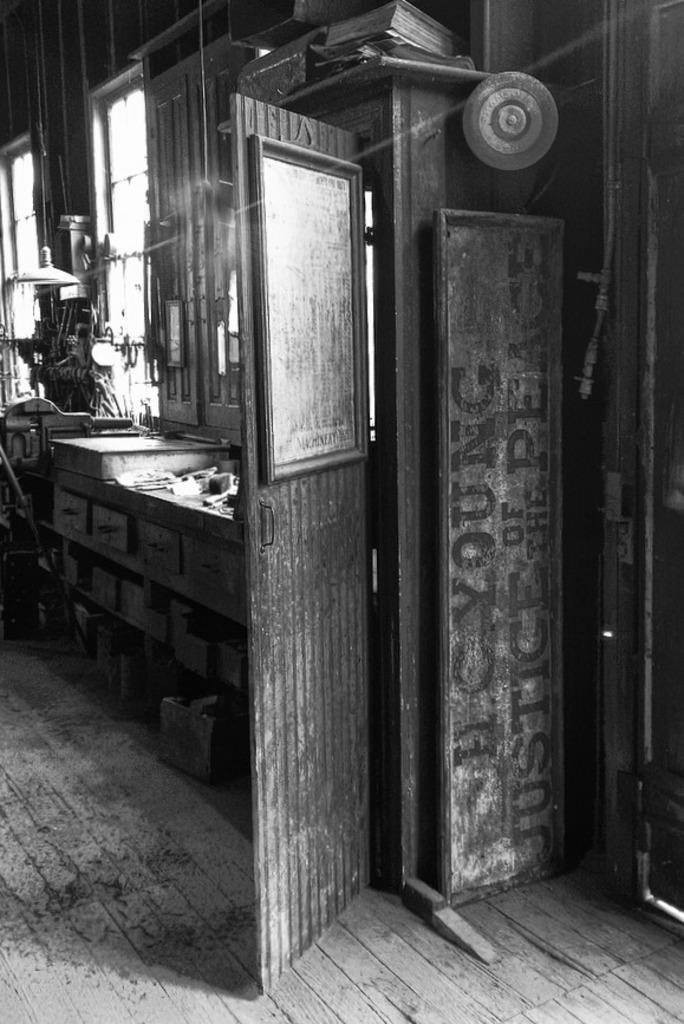What is the color scheme of the image? The image is black and white. What type of architectural features can be seen in the image? There are doors and cupboards in the image. What can be seen in the image that allows natural light to enter? There are windows in the image. What else can be seen in the image besides the architectural features? There are some objects in the image. What type of knife is being used to cut the yam in the image? There is no knife or yam present in the image; it only features doors, cupboards, windows, and some unspecified objects. 